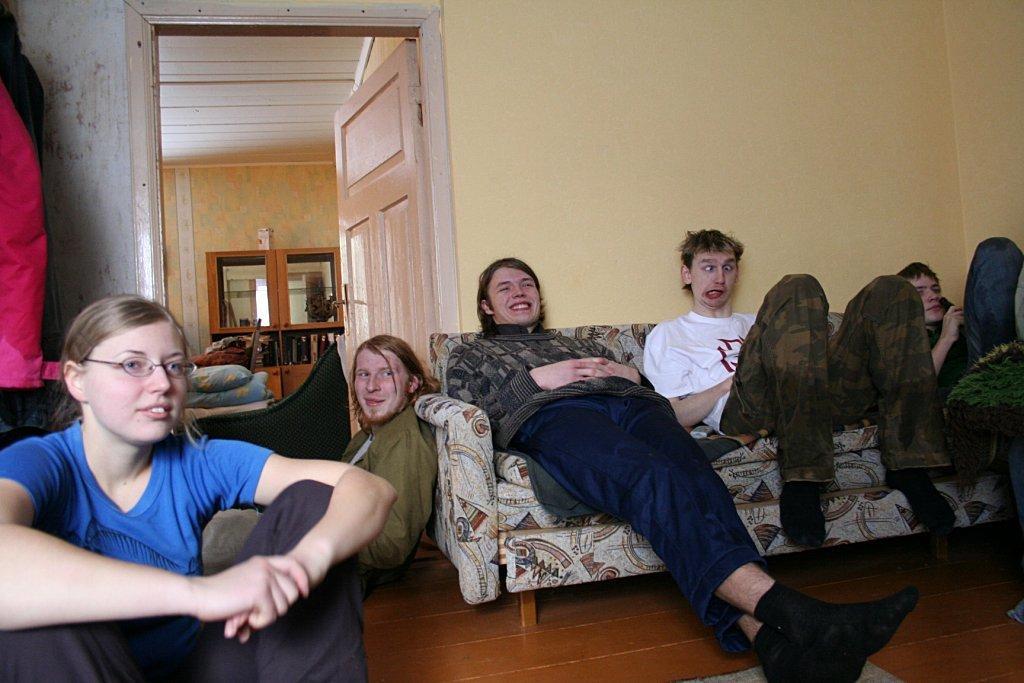Could you give a brief overview of what you see in this image? This image consists of five persons. In the front, we can see a sofa. At the bottom, there is a floor. In the background, we can see a wall along with the door. 